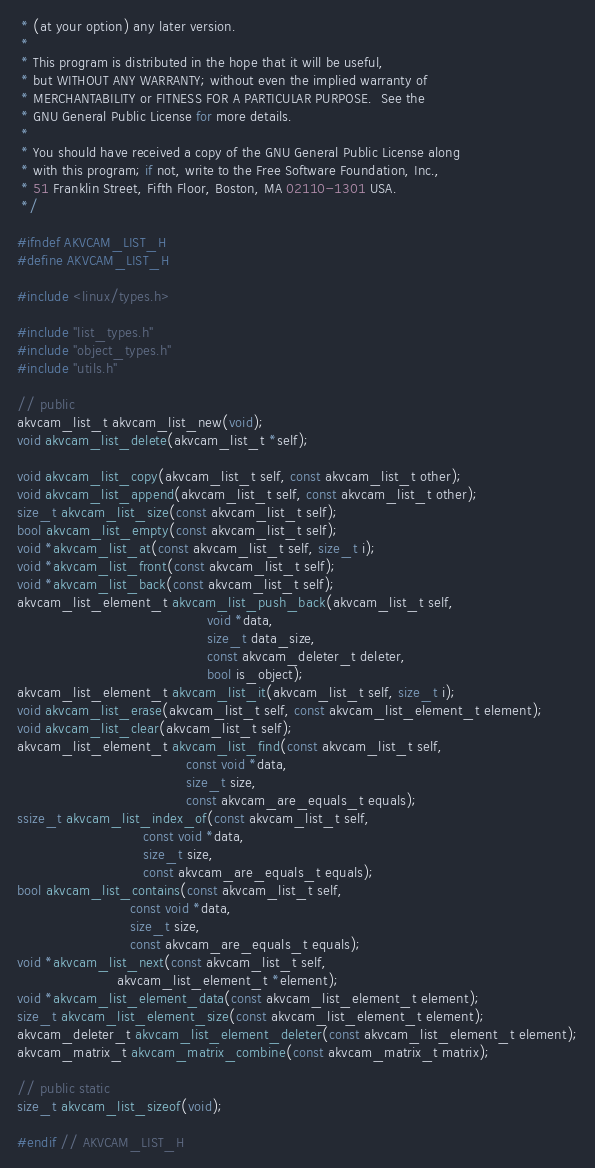Convert code to text. <code><loc_0><loc_0><loc_500><loc_500><_C_> * (at your option) any later version.
 *
 * This program is distributed in the hope that it will be useful,
 * but WITHOUT ANY WARRANTY; without even the implied warranty of
 * MERCHANTABILITY or FITNESS FOR A PARTICULAR PURPOSE.  See the
 * GNU General Public License for more details.
 *
 * You should have received a copy of the GNU General Public License along
 * with this program; if not, write to the Free Software Foundation, Inc.,
 * 51 Franklin Street, Fifth Floor, Boston, MA 02110-1301 USA.
 */

#ifndef AKVCAM_LIST_H
#define AKVCAM_LIST_H

#include <linux/types.h>

#include "list_types.h"
#include "object_types.h"
#include "utils.h"

// public
akvcam_list_t akvcam_list_new(void);
void akvcam_list_delete(akvcam_list_t *self);

void akvcam_list_copy(akvcam_list_t self, const akvcam_list_t other);
void akvcam_list_append(akvcam_list_t self, const akvcam_list_t other);
size_t akvcam_list_size(const akvcam_list_t self);
bool akvcam_list_empty(const akvcam_list_t self);
void *akvcam_list_at(const akvcam_list_t self, size_t i);
void *akvcam_list_front(const akvcam_list_t self);
void *akvcam_list_back(const akvcam_list_t self);
akvcam_list_element_t akvcam_list_push_back(akvcam_list_t self,
                                            void *data,
                                            size_t data_size,
                                            const akvcam_deleter_t deleter,
                                            bool is_object);
akvcam_list_element_t akvcam_list_it(akvcam_list_t self, size_t i);
void akvcam_list_erase(akvcam_list_t self, const akvcam_list_element_t element);
void akvcam_list_clear(akvcam_list_t self);
akvcam_list_element_t akvcam_list_find(const akvcam_list_t self,
                                       const void *data,
                                       size_t size,
                                       const akvcam_are_equals_t equals);
ssize_t akvcam_list_index_of(const akvcam_list_t self,
                             const void *data,
                             size_t size,
                             const akvcam_are_equals_t equals);
bool akvcam_list_contains(const akvcam_list_t self,
                          const void *data,
                          size_t size,
                          const akvcam_are_equals_t equals);
void *akvcam_list_next(const akvcam_list_t self,
                       akvcam_list_element_t *element);
void *akvcam_list_element_data(const akvcam_list_element_t element);
size_t akvcam_list_element_size(const akvcam_list_element_t element);
akvcam_deleter_t akvcam_list_element_deleter(const akvcam_list_element_t element);
akvcam_matrix_t akvcam_matrix_combine(const akvcam_matrix_t matrix);

// public static
size_t akvcam_list_sizeof(void);

#endif // AKVCAM_LIST_H
</code> 